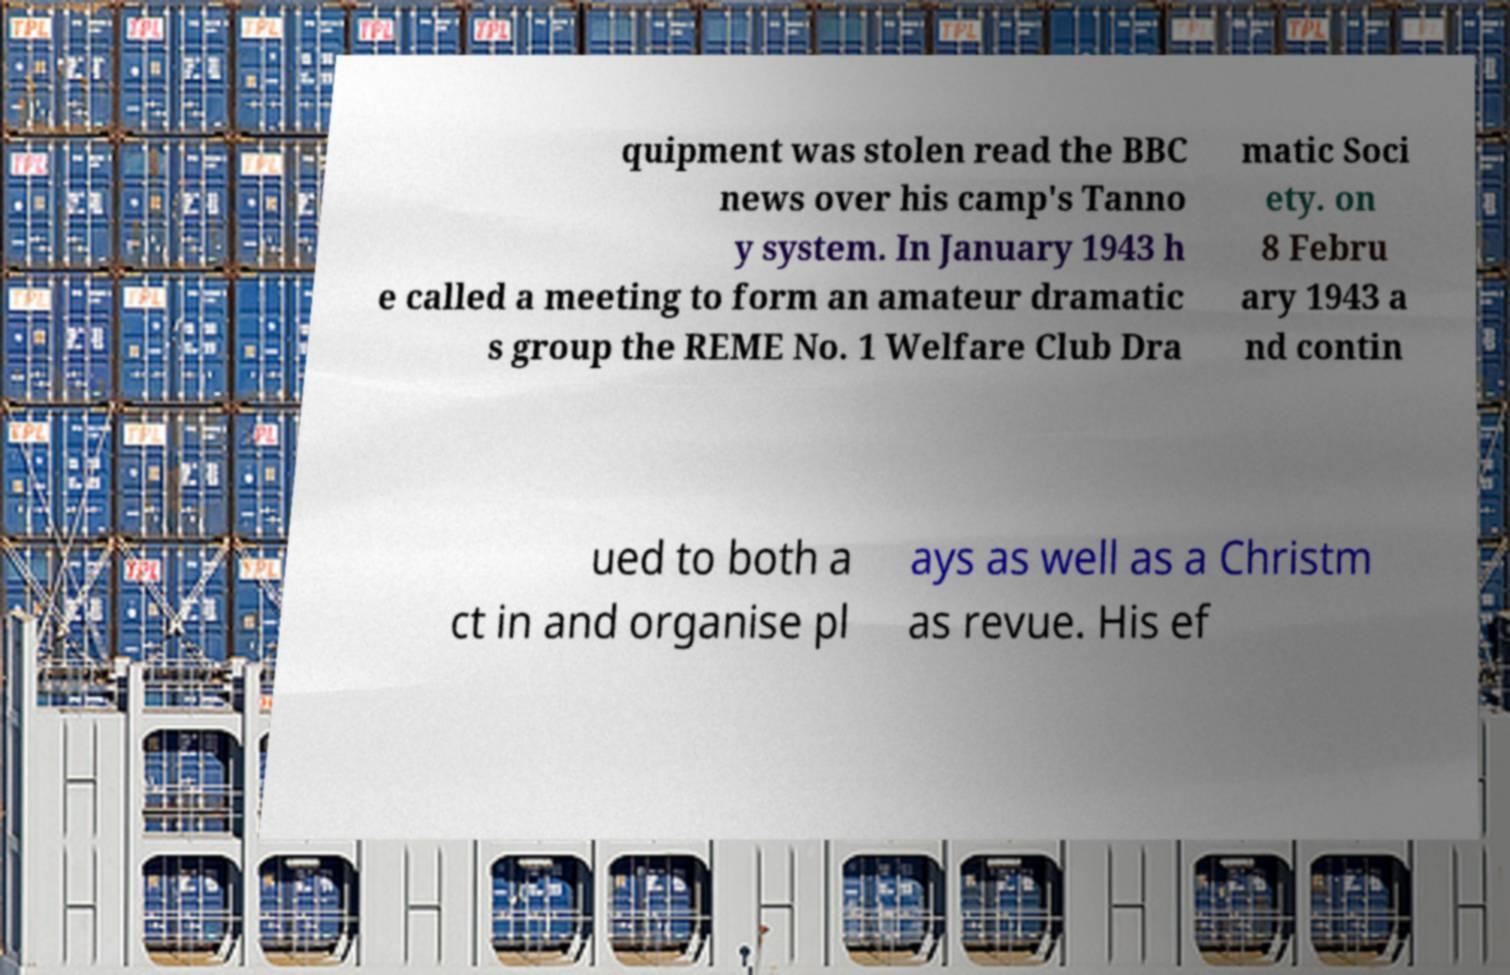I need the written content from this picture converted into text. Can you do that? quipment was stolen read the BBC news over his camp's Tanno y system. In January 1943 h e called a meeting to form an amateur dramatic s group the REME No. 1 Welfare Club Dra matic Soci ety. on 8 Febru ary 1943 a nd contin ued to both a ct in and organise pl ays as well as a Christm as revue. His ef 